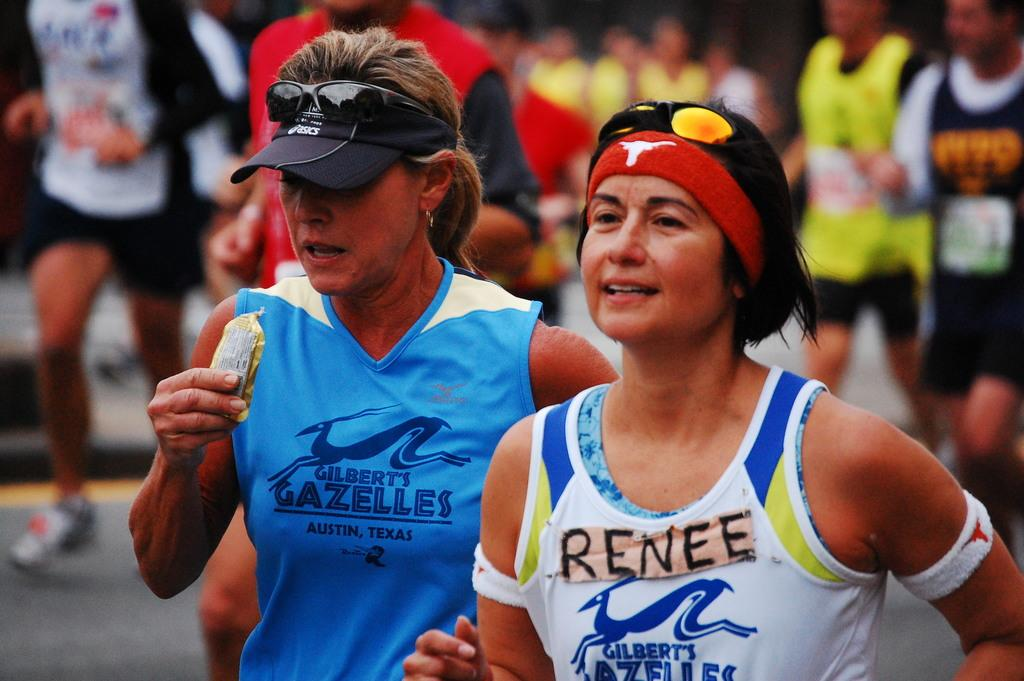<image>
Give a short and clear explanation of the subsequent image. A woman is running in a race wearing a shirt that says "Renee." 